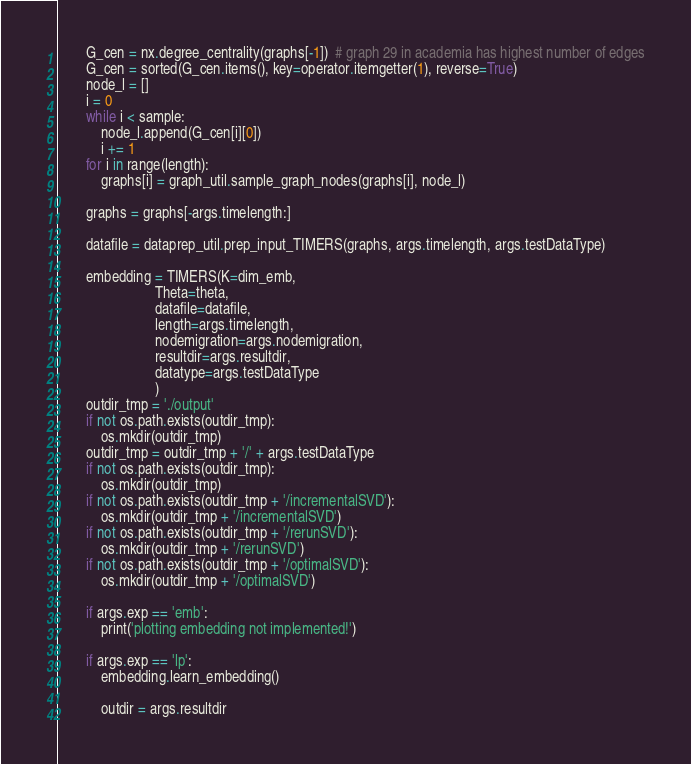<code> <loc_0><loc_0><loc_500><loc_500><_Python_>        G_cen = nx.degree_centrality(graphs[-1])  # graph 29 in academia has highest number of edges
        G_cen = sorted(G_cen.items(), key=operator.itemgetter(1), reverse=True)
        node_l = []
        i = 0
        while i < sample:
            node_l.append(G_cen[i][0])
            i += 1
        for i in range(length):
            graphs[i] = graph_util.sample_graph_nodes(graphs[i], node_l)

        graphs = graphs[-args.timelength:]

        datafile = dataprep_util.prep_input_TIMERS(graphs, args.timelength, args.testDataType)

        embedding = TIMERS(K=dim_emb,
                           Theta=theta,
                           datafile=datafile,
                           length=args.timelength,
                           nodemigration=args.nodemigration,
                           resultdir=args.resultdir,
                           datatype=args.testDataType
                           )
        outdir_tmp = './output'
        if not os.path.exists(outdir_tmp):
            os.mkdir(outdir_tmp)
        outdir_tmp = outdir_tmp + '/' + args.testDataType
        if not os.path.exists(outdir_tmp):
            os.mkdir(outdir_tmp)
        if not os.path.exists(outdir_tmp + '/incrementalSVD'):
            os.mkdir(outdir_tmp + '/incrementalSVD')
        if not os.path.exists(outdir_tmp + '/rerunSVD'):
            os.mkdir(outdir_tmp + '/rerunSVD')
        if not os.path.exists(outdir_tmp + '/optimalSVD'):
            os.mkdir(outdir_tmp + '/optimalSVD')

        if args.exp == 'emb':
            print('plotting embedding not implemented!')

        if args.exp == 'lp':
            embedding.learn_embedding()

            outdir = args.resultdir</code> 